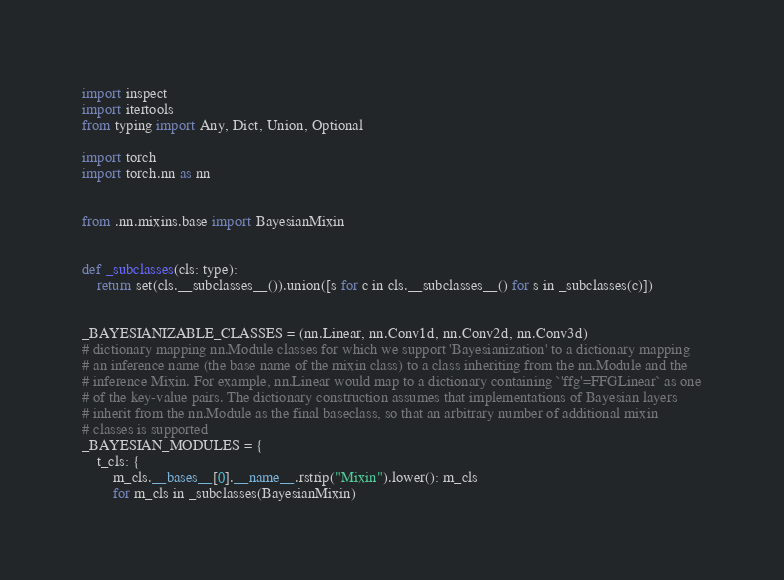Convert code to text. <code><loc_0><loc_0><loc_500><loc_500><_Python_>import inspect
import itertools
from typing import Any, Dict, Union, Optional

import torch
import torch.nn as nn


from .nn.mixins.base import BayesianMixin


def _subclasses(cls: type):
    return set(cls.__subclasses__()).union([s for c in cls.__subclasses__() for s in _subclasses(c)])


_BAYESIANIZABLE_CLASSES = (nn.Linear, nn.Conv1d, nn.Conv2d, nn.Conv3d)
# dictionary mapping nn.Module classes for which we support 'Bayesianization' to a dictionary mapping
# an inference name (the base name of the mixin class) to a class inheriting from the nn.Module and the
# inference Mixin. For example, nn.Linear would map to a dictionary containing `'ffg'=FFGLinear` as one
# of the key-value pairs. The dictionary construction assumes that implementations of Bayesian layers
# inherit from the nn.Module as the final baseclass, so that an arbitrary number of additional mixin
# classes is supported
_BAYESIAN_MODULES = {
    t_cls: {
        m_cls.__bases__[0].__name__.rstrip("Mixin").lower(): m_cls
        for m_cls in _subclasses(BayesianMixin)</code> 